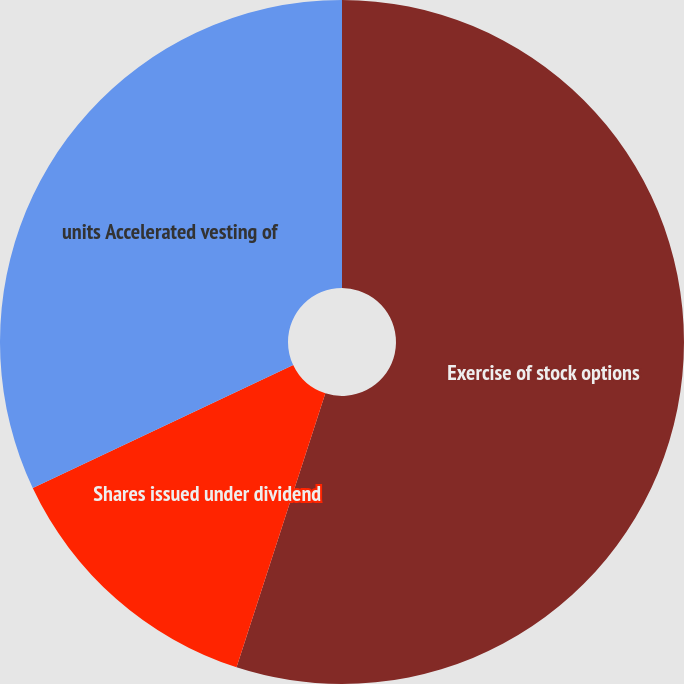<chart> <loc_0><loc_0><loc_500><loc_500><pie_chart><fcel>Exercise of stock options<fcel>Shares issued under dividend<fcel>units Accelerated vesting of<nl><fcel>54.99%<fcel>12.99%<fcel>32.02%<nl></chart> 